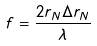Convert formula to latex. <formula><loc_0><loc_0><loc_500><loc_500>f = \frac { 2 r _ { N } \Delta r _ { N } } { \lambda }</formula> 